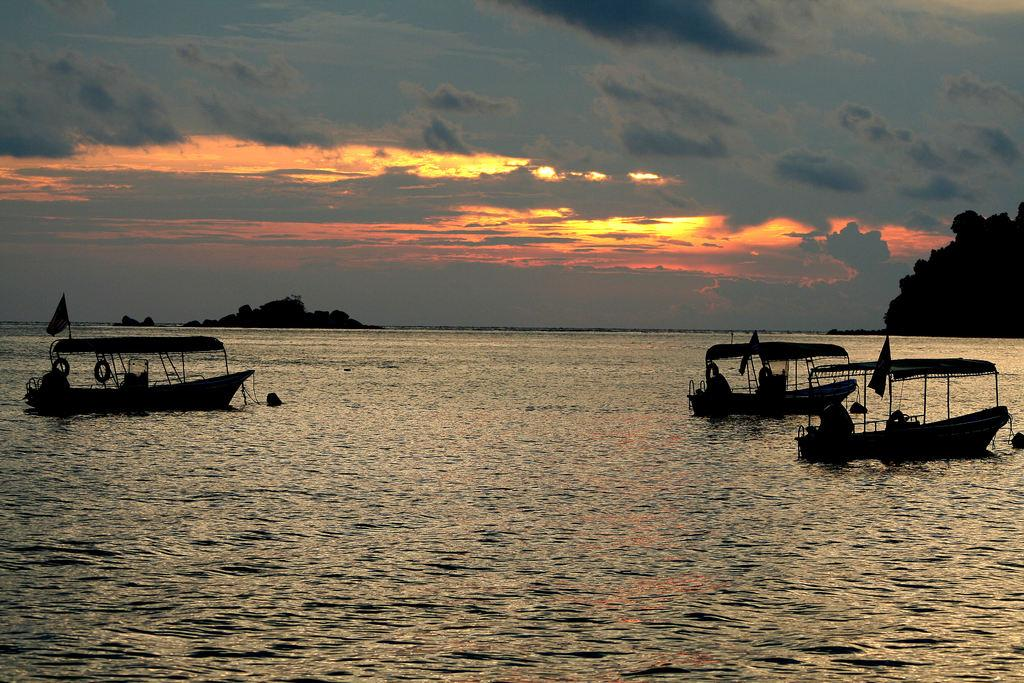What can be seen on the right side of the image? There are boats on the right side of the image. Where are the boats located? The boats are on the water. What is visible in the background of the image? There are trees in the background of the image. What thoughts are the boats having in the image? Boats do not have thoughts, as they are inanimate objects. 